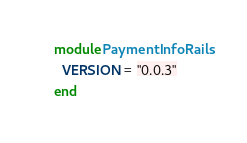Convert code to text. <code><loc_0><loc_0><loc_500><loc_500><_Ruby_>module PaymentInfoRails
  VERSION = "0.0.3"
end
</code> 